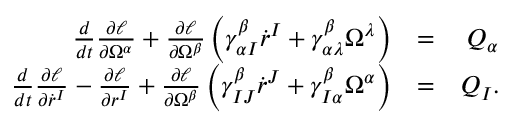<formula> <loc_0><loc_0><loc_500><loc_500>\begin{array} { r l r } { \frac { d } { d t } \frac { \partial \ell } { \partial \Omega ^ { \alpha } } + \frac { \partial \ell } { \partial \Omega ^ { \beta } } \left ( \gamma _ { \alpha I } ^ { \beta } \dot { r } ^ { I } + \gamma _ { \alpha \lambda } ^ { \beta } \Omega ^ { \lambda } \right ) } & { = } & { Q _ { \alpha } } \\ { \frac { d } { d t } \frac { \partial \ell } { \partial \dot { r } ^ { I } } - \frac { \partial \ell } { \partial r ^ { I } } + \frac { \partial \ell } { \partial \Omega ^ { \beta } } \left ( \gamma _ { I J } ^ { \beta } \dot { r } ^ { J } + \gamma _ { I \alpha } ^ { \beta } \Omega ^ { \alpha } \right ) } & { = } & { Q _ { I } . } \end{array}</formula> 